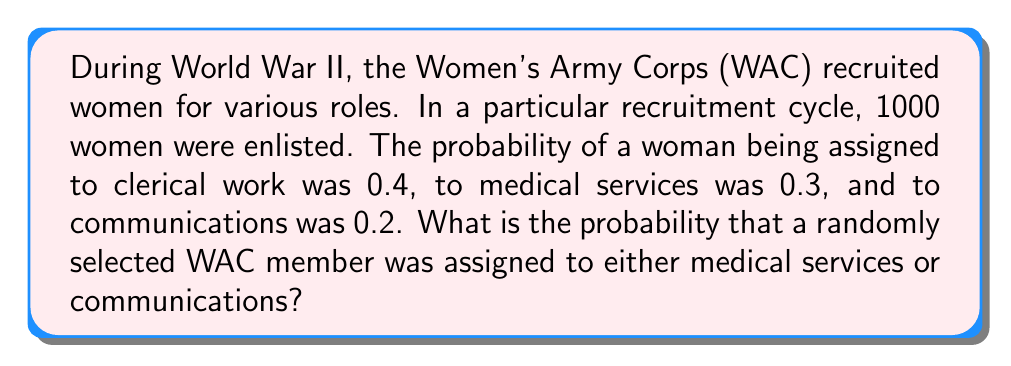Show me your answer to this math problem. Let's approach this step-by-step:

1) First, we need to identify the events:
   A: Assigned to medical services
   B: Assigned to communications

2) We're given the following probabilities:
   $P(A) = 0.3$
   $P(B) = 0.2$

3) We need to find $P(A \text{ or } B)$, which is the same as $P(A \cup B)$

4) The addition rule of probability states:
   $P(A \cup B) = P(A) + P(B) - P(A \cap B)$

5) However, in this case, the events are mutually exclusive (a woman can't be assigned to both medical services and communications simultaneously), so $P(A \cap B) = 0$

6) Therefore, we can simply add the probabilities:
   $P(A \text{ or } B) = P(A) + P(B)$

7) Substituting the values:
   $P(A \text{ or } B) = 0.3 + 0.2 = 0.5$

Thus, the probability that a randomly selected WAC member was assigned to either medical services or communications is 0.5 or 50%.
Answer: $0.5$ or $50\%$ 